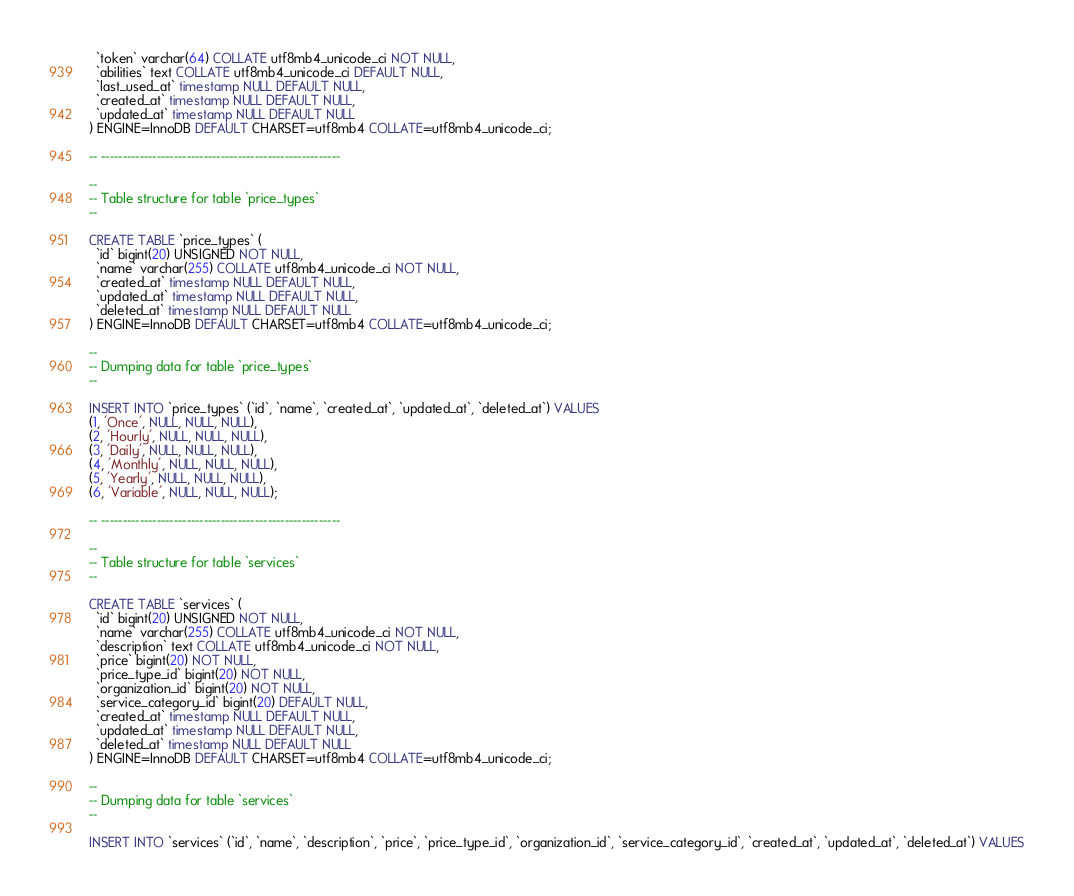<code> <loc_0><loc_0><loc_500><loc_500><_SQL_>  `token` varchar(64) COLLATE utf8mb4_unicode_ci NOT NULL,
  `abilities` text COLLATE utf8mb4_unicode_ci DEFAULT NULL,
  `last_used_at` timestamp NULL DEFAULT NULL,
  `created_at` timestamp NULL DEFAULT NULL,
  `updated_at` timestamp NULL DEFAULT NULL
) ENGINE=InnoDB DEFAULT CHARSET=utf8mb4 COLLATE=utf8mb4_unicode_ci;

-- --------------------------------------------------------

--
-- Table structure for table `price_types`
--

CREATE TABLE `price_types` (
  `id` bigint(20) UNSIGNED NOT NULL,
  `name` varchar(255) COLLATE utf8mb4_unicode_ci NOT NULL,
  `created_at` timestamp NULL DEFAULT NULL,
  `updated_at` timestamp NULL DEFAULT NULL,
  `deleted_at` timestamp NULL DEFAULT NULL
) ENGINE=InnoDB DEFAULT CHARSET=utf8mb4 COLLATE=utf8mb4_unicode_ci;

--
-- Dumping data for table `price_types`
--

INSERT INTO `price_types` (`id`, `name`, `created_at`, `updated_at`, `deleted_at`) VALUES
(1, 'Once', NULL, NULL, NULL),
(2, 'Hourly', NULL, NULL, NULL),
(3, 'Daily', NULL, NULL, NULL),
(4, 'Monthly', NULL, NULL, NULL),
(5, 'Yearly', NULL, NULL, NULL),
(6, 'Variable', NULL, NULL, NULL);

-- --------------------------------------------------------

--
-- Table structure for table `services`
--

CREATE TABLE `services` (
  `id` bigint(20) UNSIGNED NOT NULL,
  `name` varchar(255) COLLATE utf8mb4_unicode_ci NOT NULL,
  `description` text COLLATE utf8mb4_unicode_ci NOT NULL,
  `price` bigint(20) NOT NULL,
  `price_type_id` bigint(20) NOT NULL,
  `organization_id` bigint(20) NOT NULL,
  `service_category_id` bigint(20) DEFAULT NULL,
  `created_at` timestamp NULL DEFAULT NULL,
  `updated_at` timestamp NULL DEFAULT NULL,
  `deleted_at` timestamp NULL DEFAULT NULL
) ENGINE=InnoDB DEFAULT CHARSET=utf8mb4 COLLATE=utf8mb4_unicode_ci;

--
-- Dumping data for table `services`
--

INSERT INTO `services` (`id`, `name`, `description`, `price`, `price_type_id`, `organization_id`, `service_category_id`, `created_at`, `updated_at`, `deleted_at`) VALUES</code> 